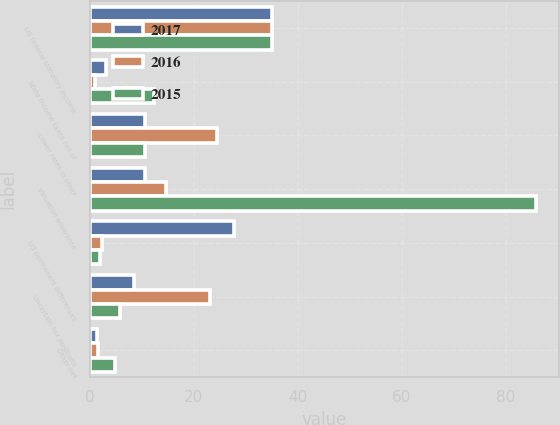<chart> <loc_0><loc_0><loc_500><loc_500><stacked_bar_chart><ecel><fcel>US federal statutory income<fcel>State income taxes net of<fcel>Lower rates in other<fcel>Valuation allowance<fcel>US permanent differences<fcel>Uncertain tax positions<fcel>Other net<nl><fcel>2017<fcel>35<fcel>3<fcel>10.5<fcel>10.5<fcel>27.8<fcel>8.4<fcel>1.4<nl><fcel>2016<fcel>35<fcel>1<fcel>24.5<fcel>14.7<fcel>2.3<fcel>23.1<fcel>1.5<nl><fcel>2015<fcel>35<fcel>12.4<fcel>10.5<fcel>85.9<fcel>1.9<fcel>5.8<fcel>4.9<nl></chart> 